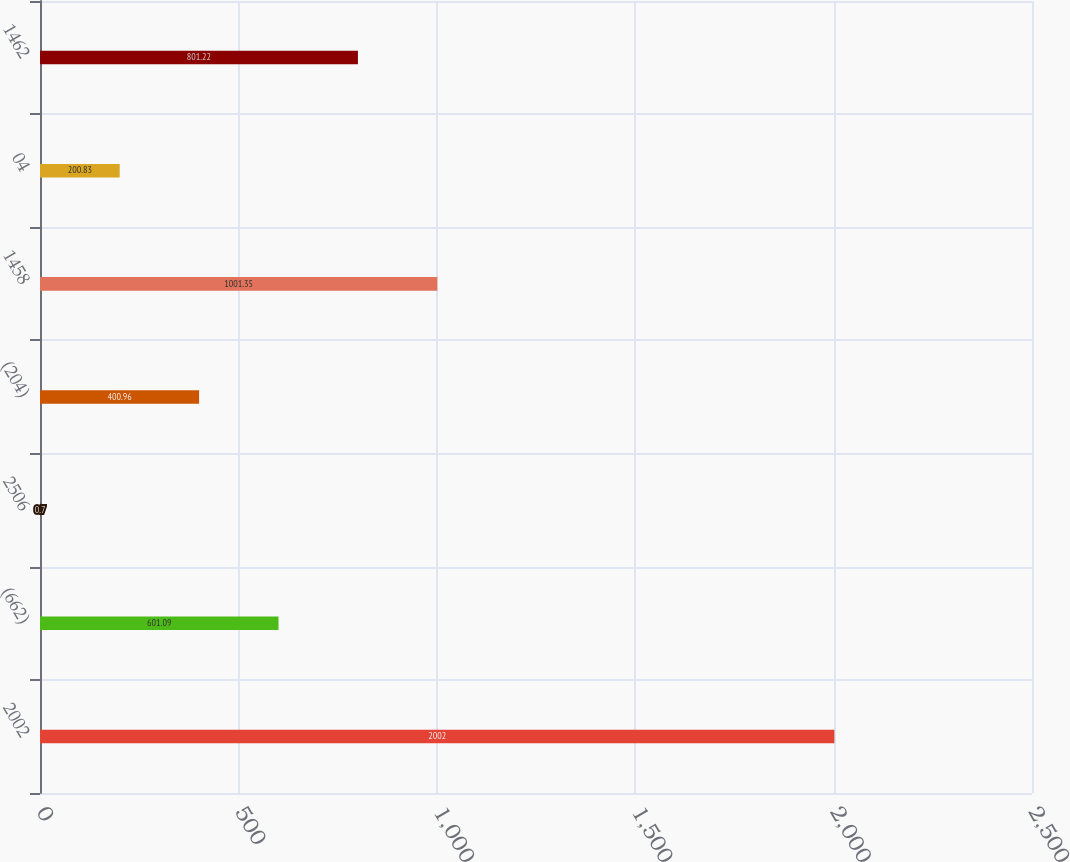<chart> <loc_0><loc_0><loc_500><loc_500><bar_chart><fcel>2002<fcel>(662)<fcel>2506<fcel>(204)<fcel>1458<fcel>04<fcel>1462<nl><fcel>2002<fcel>601.09<fcel>0.7<fcel>400.96<fcel>1001.35<fcel>200.83<fcel>801.22<nl></chart> 